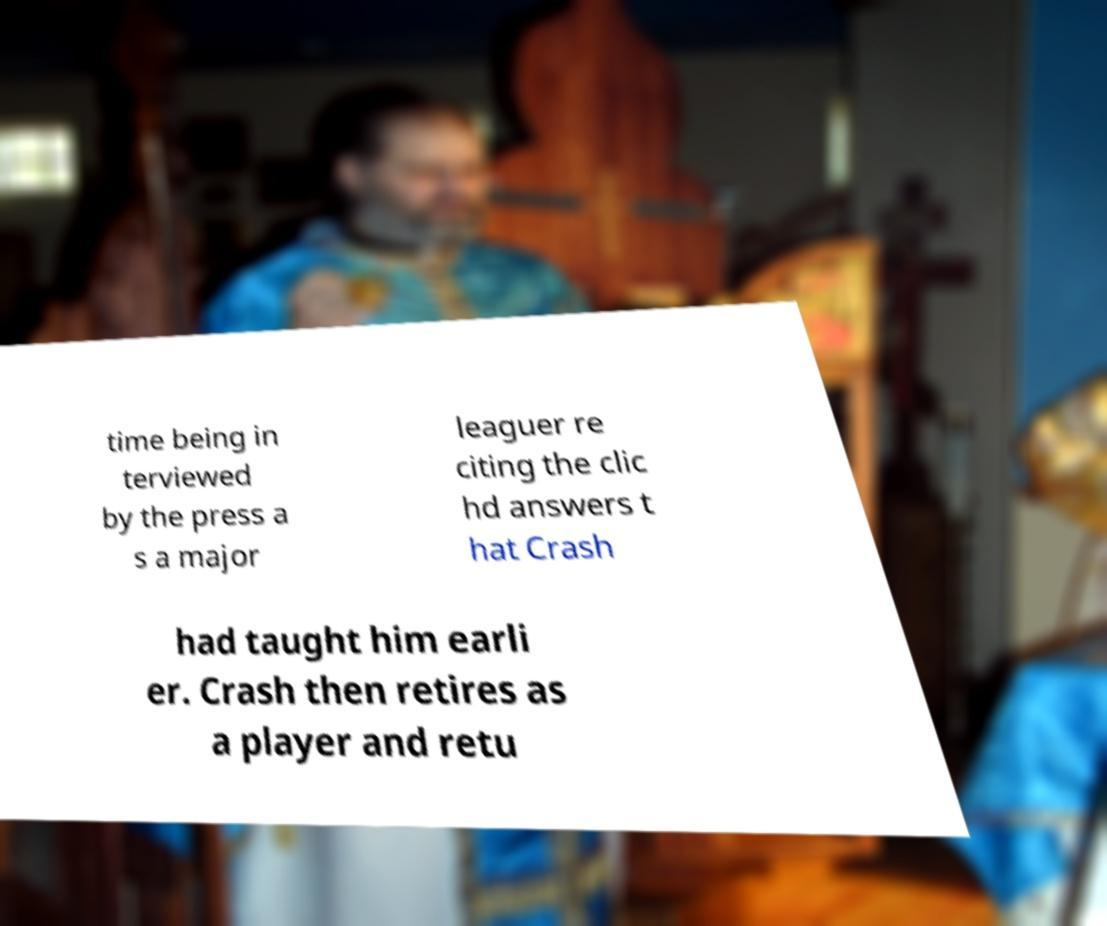Can you accurately transcribe the text from the provided image for me? time being in terviewed by the press a s a major leaguer re citing the clic hd answers t hat Crash had taught him earli er. Crash then retires as a player and retu 